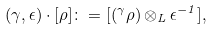<formula> <loc_0><loc_0><loc_500><loc_500>( \gamma , \epsilon ) \cdot [ \rho ] \colon = [ ( ^ { \gamma } \rho ) \otimes _ { L } \epsilon ^ { - 1 } ] ,</formula> 